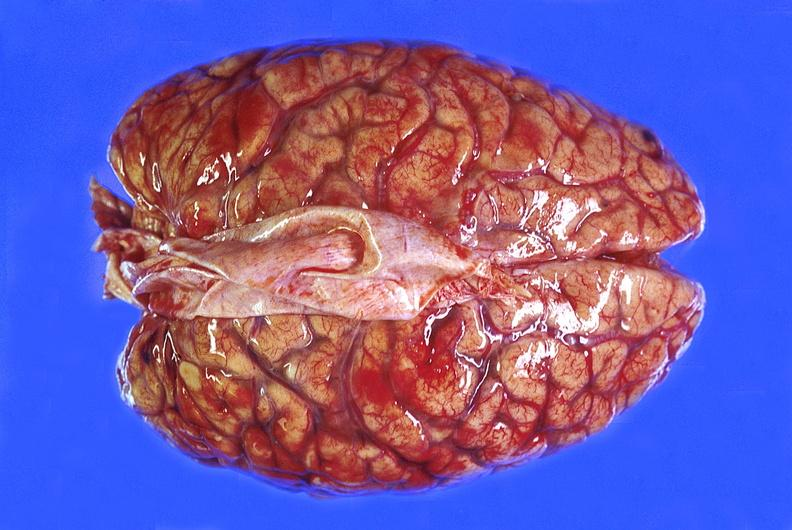s hypertension present?
Answer the question using a single word or phrase. No 